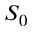Convert formula to latex. <formula><loc_0><loc_0><loc_500><loc_500>S _ { 0 }</formula> 